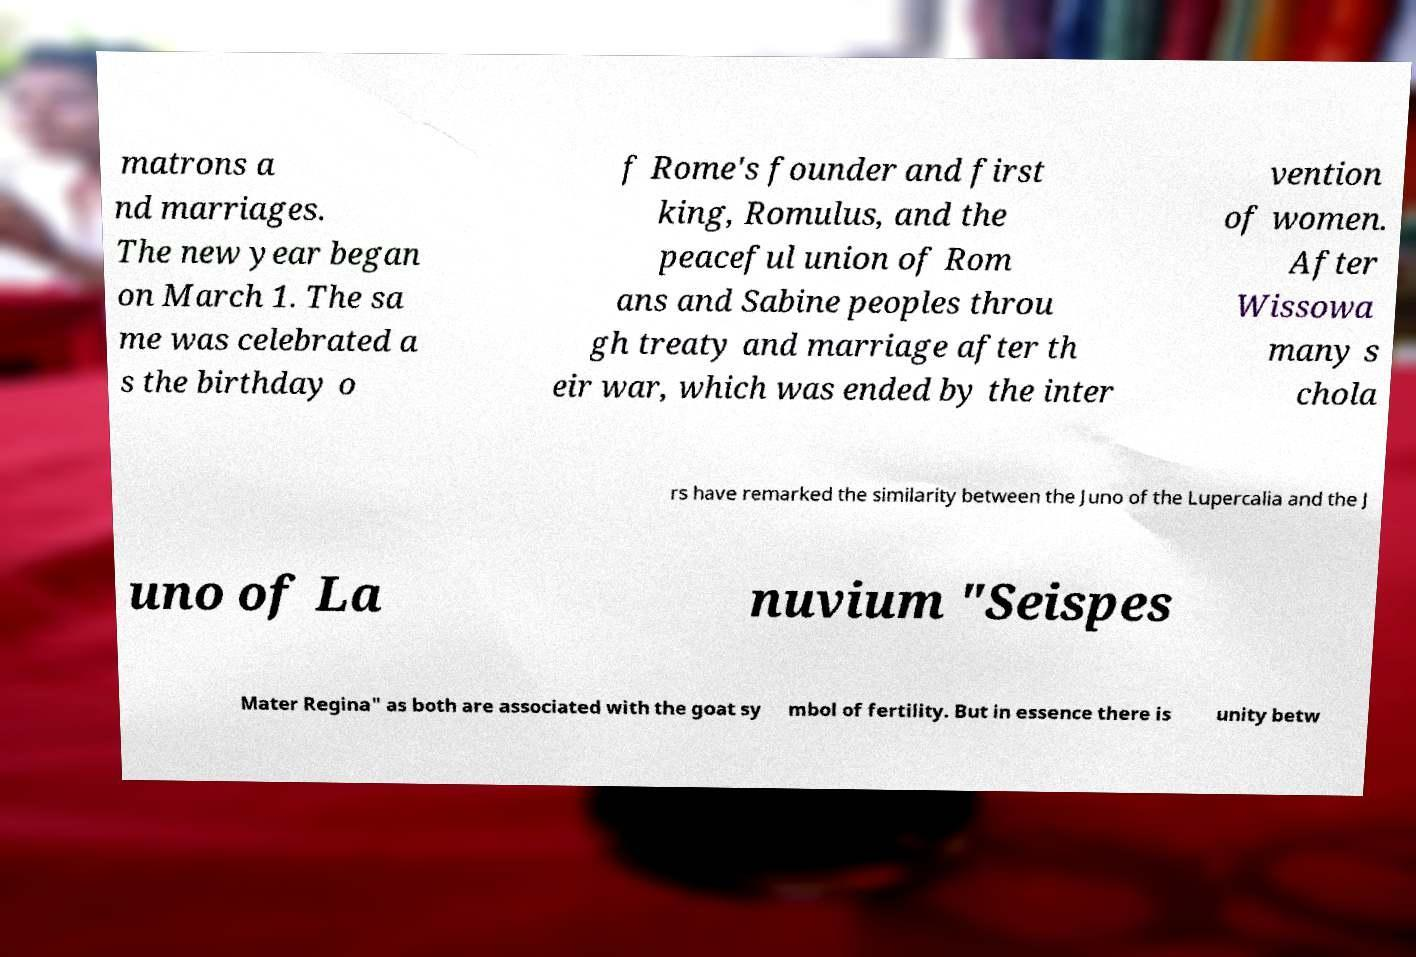What messages or text are displayed in this image? I need them in a readable, typed format. matrons a nd marriages. The new year began on March 1. The sa me was celebrated a s the birthday o f Rome's founder and first king, Romulus, and the peaceful union of Rom ans and Sabine peoples throu gh treaty and marriage after th eir war, which was ended by the inter vention of women. After Wissowa many s chola rs have remarked the similarity between the Juno of the Lupercalia and the J uno of La nuvium "Seispes Mater Regina" as both are associated with the goat sy mbol of fertility. But in essence there is unity betw 